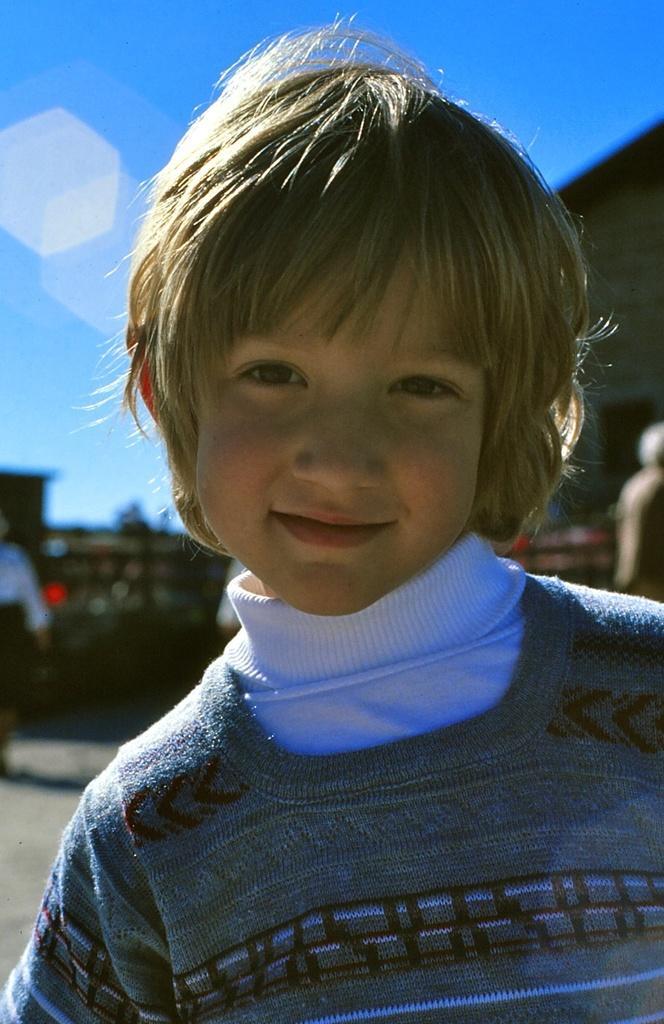Could you give a brief overview of what you see in this image? In this picture, we can see a boy. In the background, we can see a group of people, buildings. At the top, we can see a sky. 